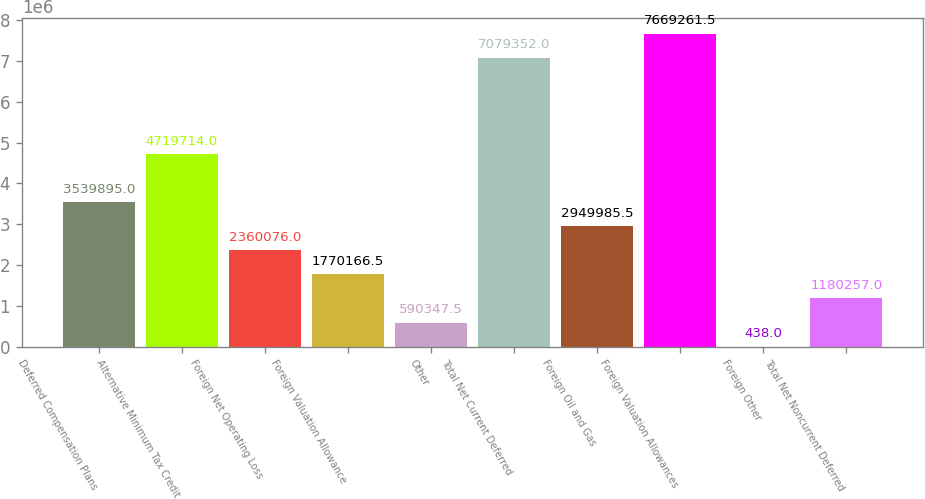<chart> <loc_0><loc_0><loc_500><loc_500><bar_chart><fcel>Deferred Compensation Plans<fcel>Alternative Minimum Tax Credit<fcel>Foreign Net Operating Loss<fcel>Foreign Valuation Allowance<fcel>Other<fcel>Total Net Current Deferred<fcel>Foreign Oil and Gas<fcel>Foreign Valuation Allowances<fcel>Foreign Other<fcel>Total Net Noncurrent Deferred<nl><fcel>3.5399e+06<fcel>4.71971e+06<fcel>2.36008e+06<fcel>1.77017e+06<fcel>590348<fcel>7.07935e+06<fcel>2.94999e+06<fcel>7.66926e+06<fcel>438<fcel>1.18026e+06<nl></chart> 